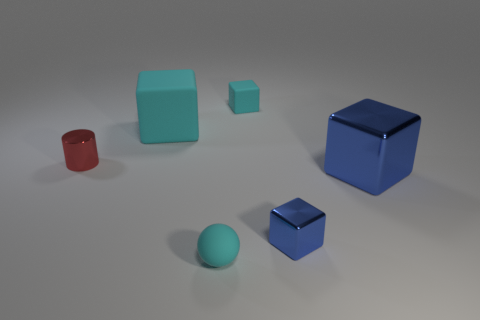Add 4 big cyan rubber cylinders. How many objects exist? 10 Subtract all cylinders. How many objects are left? 5 Add 2 metal cubes. How many metal cubes exist? 4 Subtract 0 purple blocks. How many objects are left? 6 Subtract all big green metallic objects. Subtract all small blue metal things. How many objects are left? 5 Add 6 small blue shiny objects. How many small blue shiny objects are left? 7 